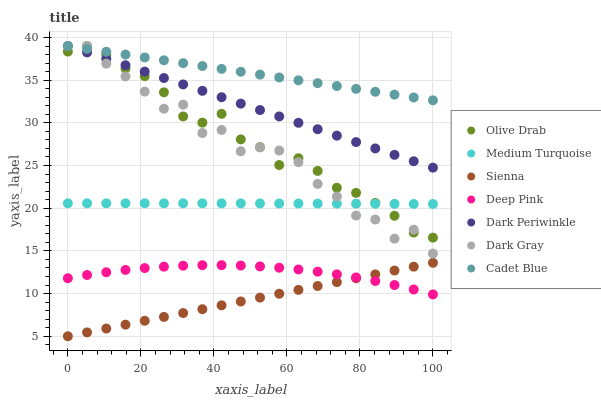Does Sienna have the minimum area under the curve?
Answer yes or no. Yes. Does Cadet Blue have the maximum area under the curve?
Answer yes or no. Yes. Does Deep Pink have the minimum area under the curve?
Answer yes or no. No. Does Deep Pink have the maximum area under the curve?
Answer yes or no. No. Is Sienna the smoothest?
Answer yes or no. Yes. Is Dark Gray the roughest?
Answer yes or no. Yes. Is Deep Pink the smoothest?
Answer yes or no. No. Is Deep Pink the roughest?
Answer yes or no. No. Does Sienna have the lowest value?
Answer yes or no. Yes. Does Deep Pink have the lowest value?
Answer yes or no. No. Does Olive Drab have the highest value?
Answer yes or no. Yes. Does Sienna have the highest value?
Answer yes or no. No. Is Deep Pink less than Olive Drab?
Answer yes or no. Yes. Is Medium Turquoise greater than Deep Pink?
Answer yes or no. Yes. Does Dark Gray intersect Cadet Blue?
Answer yes or no. Yes. Is Dark Gray less than Cadet Blue?
Answer yes or no. No. Is Dark Gray greater than Cadet Blue?
Answer yes or no. No. Does Deep Pink intersect Olive Drab?
Answer yes or no. No. 